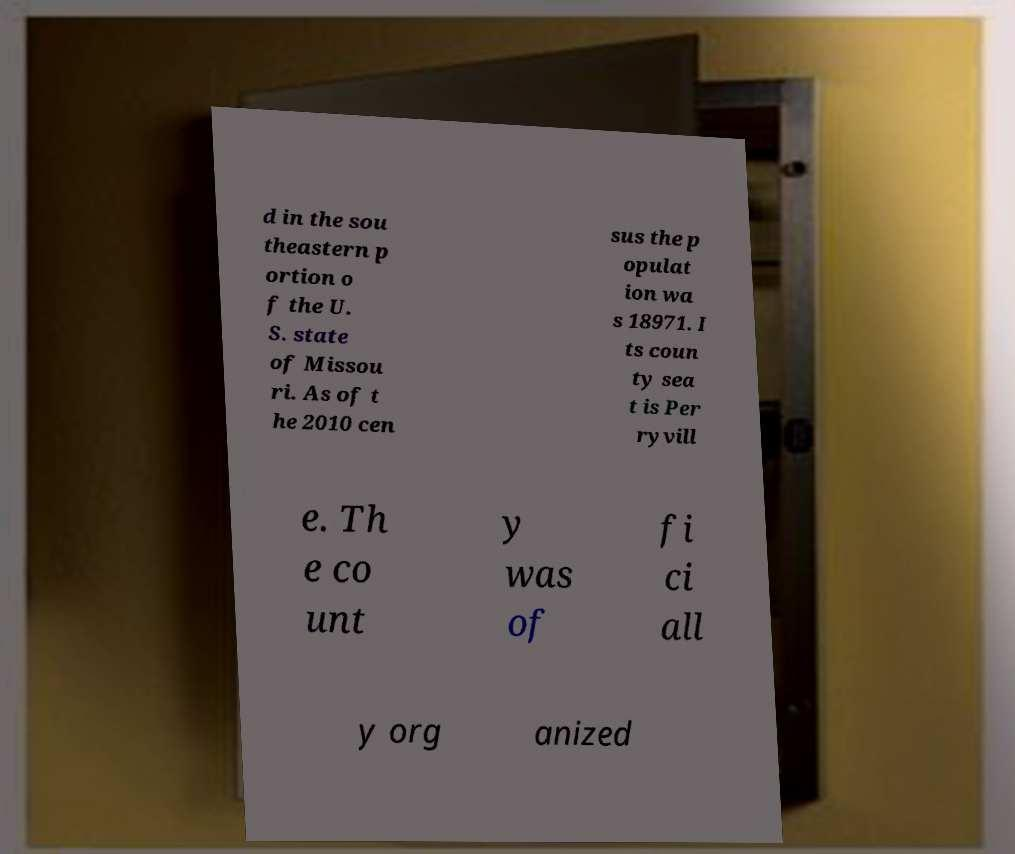Could you assist in decoding the text presented in this image and type it out clearly? d in the sou theastern p ortion o f the U. S. state of Missou ri. As of t he 2010 cen sus the p opulat ion wa s 18971. I ts coun ty sea t is Per ryvill e. Th e co unt y was of fi ci all y org anized 